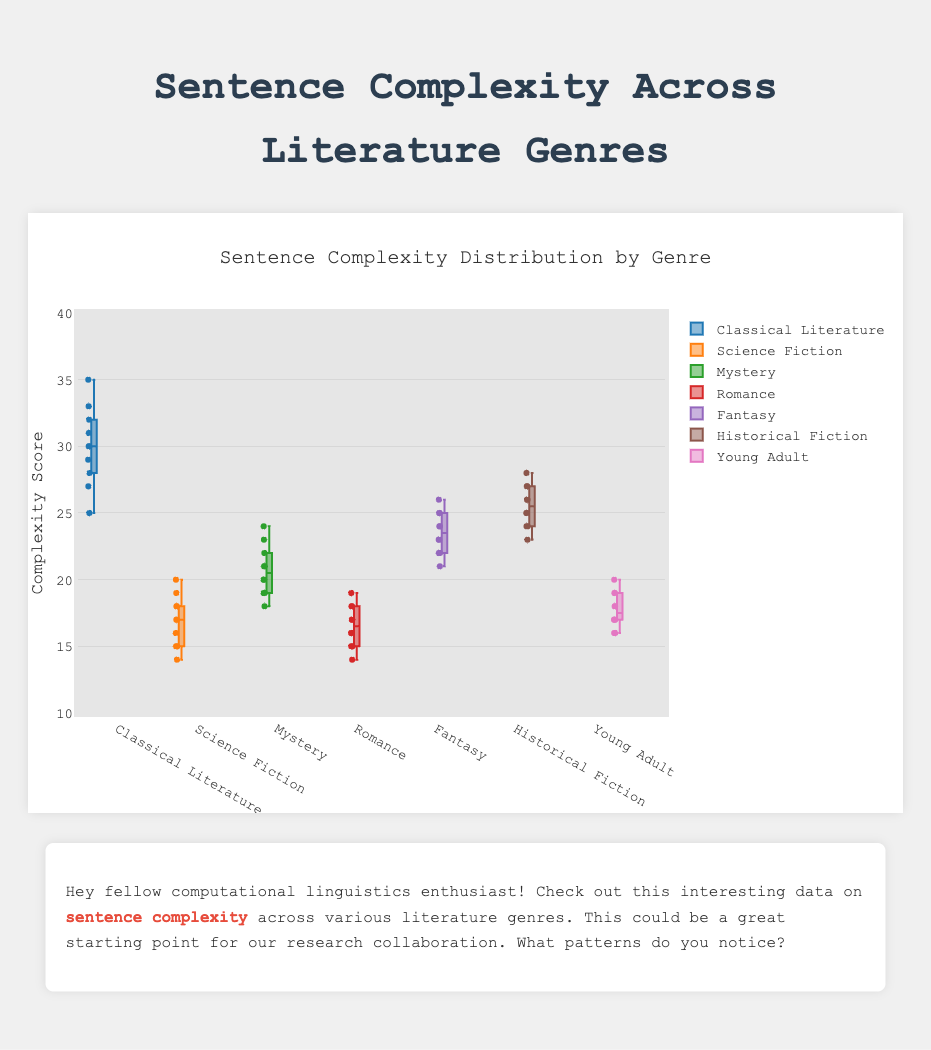Which genre has the highest median sentence complexity? The median sentence complexity is shown by the central line within each box. For Classical Literature, the median line is highest among all genres.
Answer: Classical Literature What is the range of sentence complexity scores for Science Fiction? The range is determined by subtracting the minimum value from the maximum value within the whiskers of the box plot for Science Fiction. The minimum value is 14 and the maximum value is 20, thus the range is 20 - 14 = 6.
Answer: 6 Which genre has the most variability in sentence complexity? The variability is indicated by the length of the box and whiskers. Classical Literature has the longest box and whiskers, indicating the most variability in sentence complexity.
Answer: Classical Literature Which genres have at least one outlier in sentence complexity? Outliers are marked with individual points beyond the whiskers of the box plots. Classical Literature and Mystery have individual points beyond their whiskers, showing outliers.
Answer: Classical Literature, Mystery Comparing Romance and Mystery, which genre generally has simpler sentences? Simpler sentences correspond to lower complexity scores. The boxes and whiskers for Romance are positioned lower on the y-axis than those for Mystery, indicating generally simpler sentences in Romance.
Answer: Romance What is the interquartile range (IQR) for Historical Fiction? The IQR is the difference between the upper quartile (75th percentile) and the lower quartile (25th percentile) values of the box plot. For Historical Fiction, the IQR can be approximated by examining the top and bottom of the box. The values are roughly 27 and 24.5, so IQR = 27 - 24.5 = 2.5.
Answer: 2.5 Which genre has the smallest minimum sentence complexity? The minimum complexity is represented by the bottom of the whisker for each box plot. Romance and Science Fiction have similar minimum sentence complexities, both around 14.
Answer: Romance, Science Fiction How does the median sentence complexity for Fantasy compare to that of Historical Fiction? The central line in each box shows the median value. Fantasy's median line is slightly below the median line of Historical Fiction, indicating a slightly lower median complexity in Fantasy compared to Historical Fiction.
Answer: Lower What is the approximate maximum sentence complexity score for Young Adult? The maximum sentence complexity score is shown by the top of the upper whisker for Young Adult. This value is around 20.
Answer: 20 